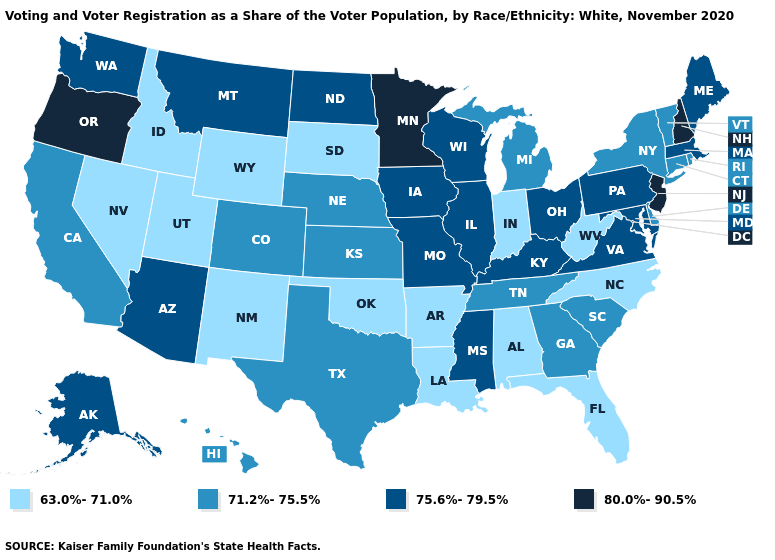What is the value of New Hampshire?
Answer briefly. 80.0%-90.5%. Does Mississippi have the same value as Washington?
Concise answer only. Yes. Is the legend a continuous bar?
Give a very brief answer. No. What is the value of South Dakota?
Be succinct. 63.0%-71.0%. Name the states that have a value in the range 63.0%-71.0%?
Give a very brief answer. Alabama, Arkansas, Florida, Idaho, Indiana, Louisiana, Nevada, New Mexico, North Carolina, Oklahoma, South Dakota, Utah, West Virginia, Wyoming. Among the states that border Connecticut , which have the highest value?
Be succinct. Massachusetts. Name the states that have a value in the range 75.6%-79.5%?
Quick response, please. Alaska, Arizona, Illinois, Iowa, Kentucky, Maine, Maryland, Massachusetts, Mississippi, Missouri, Montana, North Dakota, Ohio, Pennsylvania, Virginia, Washington, Wisconsin. Which states have the lowest value in the MidWest?
Answer briefly. Indiana, South Dakota. Among the states that border Indiana , which have the lowest value?
Keep it brief. Michigan. Among the states that border Oklahoma , does Kansas have the lowest value?
Short answer required. No. Among the states that border North Carolina , does Virginia have the highest value?
Be succinct. Yes. Name the states that have a value in the range 80.0%-90.5%?
Short answer required. Minnesota, New Hampshire, New Jersey, Oregon. Does Nevada have the lowest value in the USA?
Answer briefly. Yes. Does Colorado have the same value as Georgia?
Short answer required. Yes. Is the legend a continuous bar?
Answer briefly. No. 